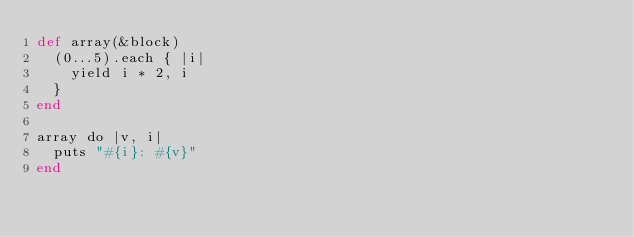Convert code to text. <code><loc_0><loc_0><loc_500><loc_500><_Crystal_>def array(&block)
	(0...5).each { |i|
		yield i * 2, i
	}
end

array do |v, i|
	puts "#{i}: #{v}"
end</code> 